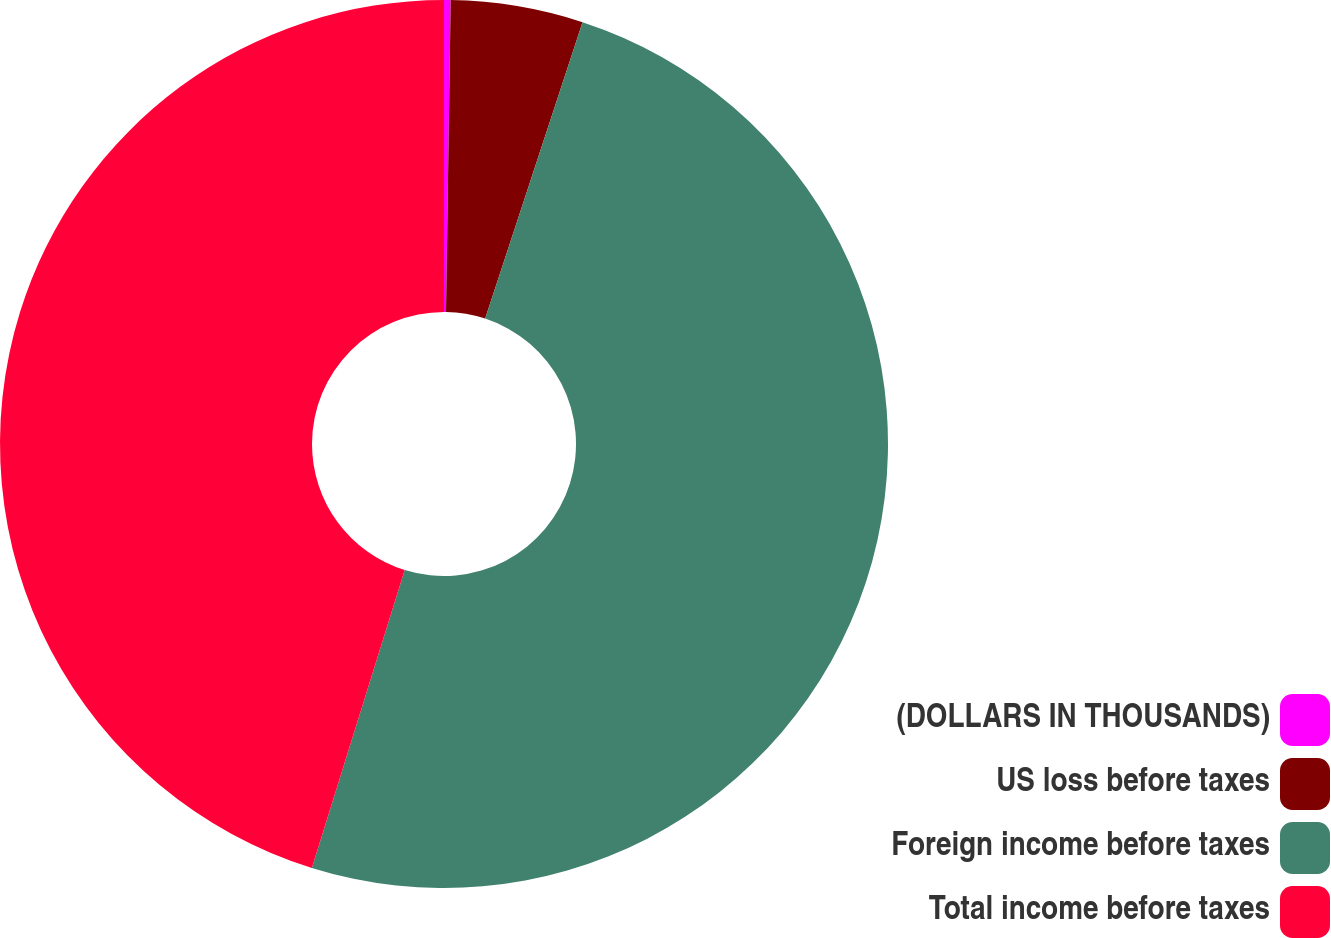Convert chart to OTSL. <chart><loc_0><loc_0><loc_500><loc_500><pie_chart><fcel>(DOLLARS IN THOUSANDS)<fcel>US loss before taxes<fcel>Foreign income before taxes<fcel>Total income before taxes<nl><fcel>0.24%<fcel>4.81%<fcel>49.76%<fcel>45.19%<nl></chart> 